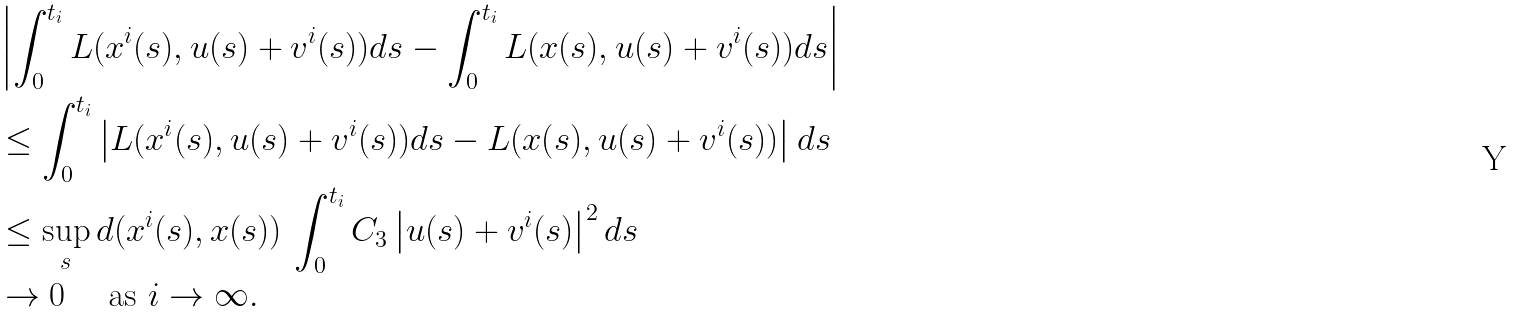<formula> <loc_0><loc_0><loc_500><loc_500>& \left | \int _ { 0 } ^ { t _ { i } } L ( x ^ { i } ( s ) , u ( s ) + v ^ { i } ( s ) ) d s - \int _ { 0 } ^ { t _ { i } } L ( x ( s ) , u ( s ) + v ^ { i } ( s ) ) d s \right | \\ & \leq \int _ { 0 } ^ { t _ { i } } \left | L ( x ^ { i } ( s ) , u ( s ) + v ^ { i } ( s ) ) d s - L ( x ( s ) , u ( s ) + v ^ { i } ( s ) ) \right | d s \\ & \leq \sup _ { s } d ( x ^ { i } ( s ) , x ( s ) ) \, \int _ { 0 } ^ { t _ { i } } C _ { 3 } \left | u ( s ) + v ^ { i } ( s ) \right | ^ { 2 } d s \\ & \to 0 \quad \text { as } i \to \infty .</formula> 